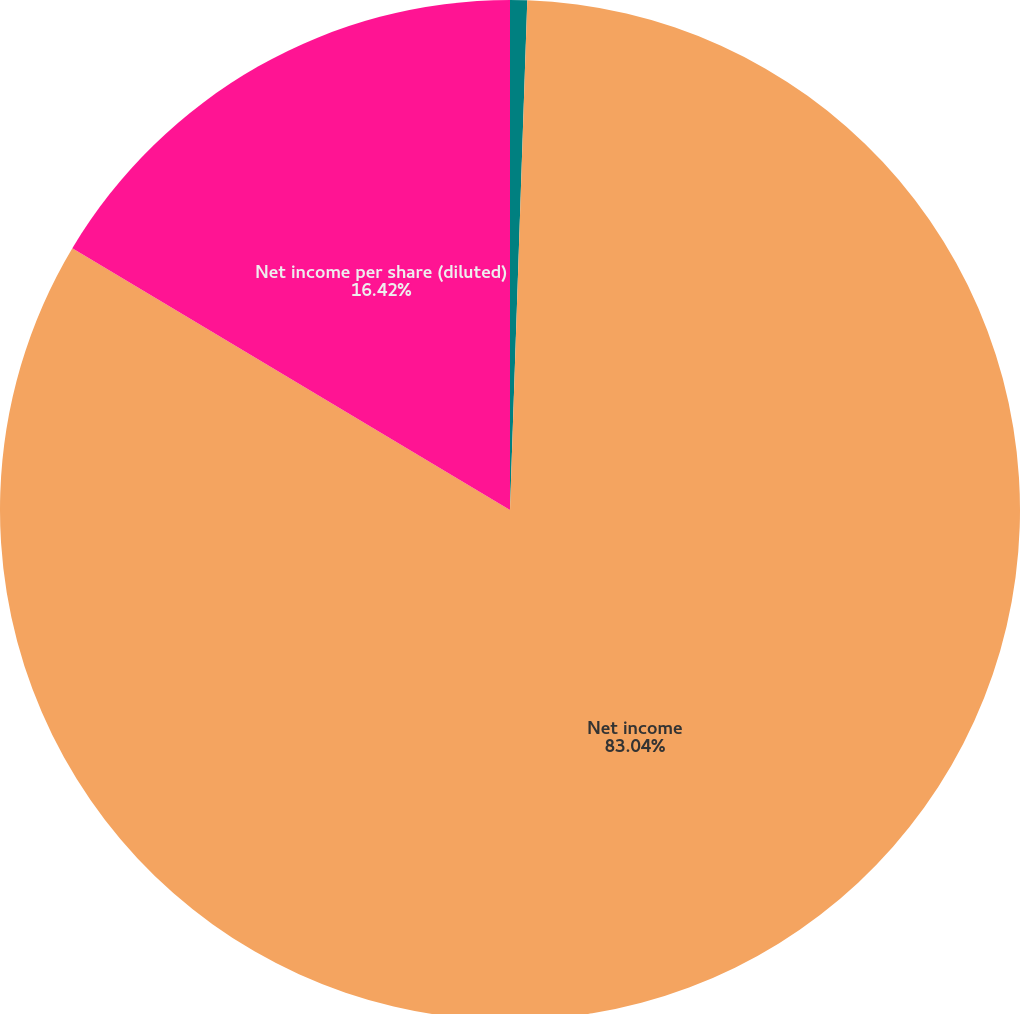Convert chart. <chart><loc_0><loc_0><loc_500><loc_500><pie_chart><fcel>Income from continuing<fcel>Net income<fcel>Net income per share (diluted)<nl><fcel>0.54%<fcel>83.04%<fcel>16.42%<nl></chart> 